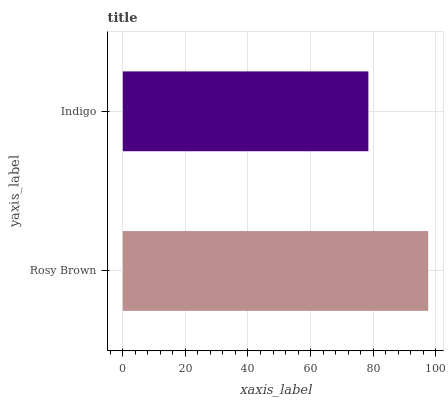Is Indigo the minimum?
Answer yes or no. Yes. Is Rosy Brown the maximum?
Answer yes or no. Yes. Is Indigo the maximum?
Answer yes or no. No. Is Rosy Brown greater than Indigo?
Answer yes or no. Yes. Is Indigo less than Rosy Brown?
Answer yes or no. Yes. Is Indigo greater than Rosy Brown?
Answer yes or no. No. Is Rosy Brown less than Indigo?
Answer yes or no. No. Is Rosy Brown the high median?
Answer yes or no. Yes. Is Indigo the low median?
Answer yes or no. Yes. Is Indigo the high median?
Answer yes or no. No. Is Rosy Brown the low median?
Answer yes or no. No. 